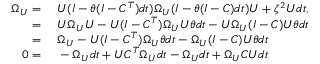Convert formula to latex. <formula><loc_0><loc_0><loc_500><loc_500>\begin{array} { r l } { \Omega _ { U } = } & \ U ( I - \theta ( I - C ^ { T } ) d t ) \Omega _ { U } ( I - \theta ( I - C ) d t ) U + \zeta ^ { 2 } U d t , } \\ { = } & \ U \Omega _ { U } U - U ( I - C ^ { T } ) \Omega _ { U } U \theta d t - U \Omega _ { U } ( I - C ) U \theta d t } \\ { = } & \ \Omega _ { U } - U ( I - C ^ { T } ) \Omega _ { U } \theta d t - \Omega _ { U } ( I - C ) U \theta d t } \\ { 0 = } & \ - \Omega _ { U } d t + U C ^ { T } \Omega _ { U } d t - \Omega _ { U } d t + \Omega _ { U } C U d t } \end{array}</formula> 